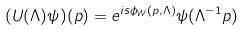<formula> <loc_0><loc_0><loc_500><loc_500>( U ( \Lambda ) \psi ) ( p ) = e ^ { i s \phi _ { W } ( p , \Lambda ) } \psi ( \Lambda ^ { - 1 } p )</formula> 